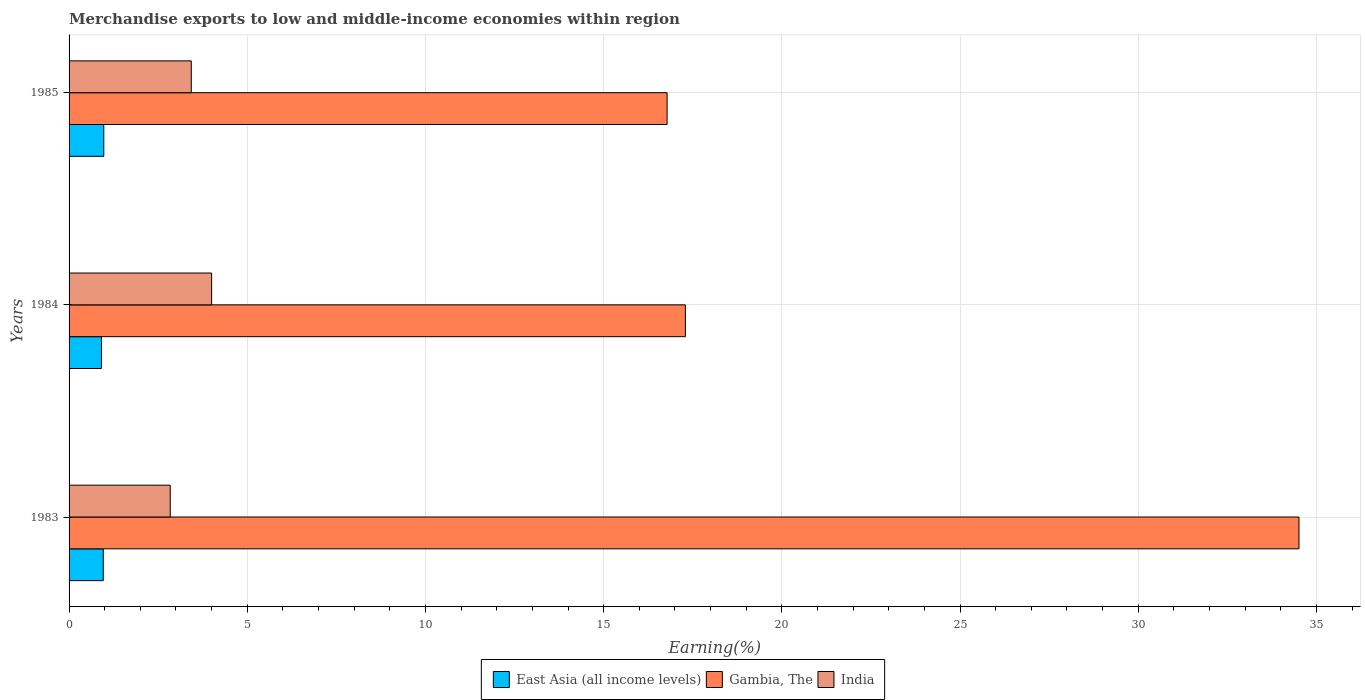How many different coloured bars are there?
Your response must be concise. 3. What is the percentage of amount earned from merchandise exports in East Asia (all income levels) in 1984?
Make the answer very short. 0.91. Across all years, what is the maximum percentage of amount earned from merchandise exports in East Asia (all income levels)?
Your answer should be very brief. 0.97. Across all years, what is the minimum percentage of amount earned from merchandise exports in Gambia, The?
Offer a very short reply. 16.78. What is the total percentage of amount earned from merchandise exports in East Asia (all income levels) in the graph?
Make the answer very short. 2.84. What is the difference between the percentage of amount earned from merchandise exports in India in 1983 and that in 1984?
Keep it short and to the point. -1.16. What is the difference between the percentage of amount earned from merchandise exports in East Asia (all income levels) in 1983 and the percentage of amount earned from merchandise exports in Gambia, The in 1984?
Give a very brief answer. -16.33. What is the average percentage of amount earned from merchandise exports in Gambia, The per year?
Provide a succinct answer. 22.86. In the year 1983, what is the difference between the percentage of amount earned from merchandise exports in India and percentage of amount earned from merchandise exports in East Asia (all income levels)?
Give a very brief answer. 1.88. In how many years, is the percentage of amount earned from merchandise exports in India greater than 13 %?
Keep it short and to the point. 0. What is the ratio of the percentage of amount earned from merchandise exports in India in 1983 to that in 1984?
Make the answer very short. 0.71. What is the difference between the highest and the second highest percentage of amount earned from merchandise exports in India?
Your answer should be compact. 0.57. What is the difference between the highest and the lowest percentage of amount earned from merchandise exports in India?
Give a very brief answer. 1.16. In how many years, is the percentage of amount earned from merchandise exports in East Asia (all income levels) greater than the average percentage of amount earned from merchandise exports in East Asia (all income levels) taken over all years?
Provide a succinct answer. 2. Is the sum of the percentage of amount earned from merchandise exports in India in 1984 and 1985 greater than the maximum percentage of amount earned from merchandise exports in East Asia (all income levels) across all years?
Provide a succinct answer. Yes. What does the 2nd bar from the top in 1983 represents?
Make the answer very short. Gambia, The. What does the 3rd bar from the bottom in 1983 represents?
Your answer should be very brief. India. Is it the case that in every year, the sum of the percentage of amount earned from merchandise exports in East Asia (all income levels) and percentage of amount earned from merchandise exports in India is greater than the percentage of amount earned from merchandise exports in Gambia, The?
Give a very brief answer. No. How many bars are there?
Your answer should be compact. 9. Are all the bars in the graph horizontal?
Give a very brief answer. Yes. How many years are there in the graph?
Offer a terse response. 3. What is the difference between two consecutive major ticks on the X-axis?
Ensure brevity in your answer.  5. Does the graph contain any zero values?
Give a very brief answer. No. Where does the legend appear in the graph?
Give a very brief answer. Bottom center. How many legend labels are there?
Provide a short and direct response. 3. How are the legend labels stacked?
Keep it short and to the point. Horizontal. What is the title of the graph?
Provide a short and direct response. Merchandise exports to low and middle-income economies within region. What is the label or title of the X-axis?
Your answer should be compact. Earning(%). What is the label or title of the Y-axis?
Your answer should be compact. Years. What is the Earning(%) of East Asia (all income levels) in 1983?
Provide a succinct answer. 0.96. What is the Earning(%) of Gambia, The in 1983?
Offer a very short reply. 34.51. What is the Earning(%) in India in 1983?
Offer a terse response. 2.84. What is the Earning(%) of East Asia (all income levels) in 1984?
Ensure brevity in your answer.  0.91. What is the Earning(%) of Gambia, The in 1984?
Your answer should be very brief. 17.29. What is the Earning(%) in India in 1984?
Offer a very short reply. 4. What is the Earning(%) of East Asia (all income levels) in 1985?
Ensure brevity in your answer.  0.97. What is the Earning(%) of Gambia, The in 1985?
Provide a short and direct response. 16.78. What is the Earning(%) of India in 1985?
Your response must be concise. 3.43. Across all years, what is the maximum Earning(%) of East Asia (all income levels)?
Give a very brief answer. 0.97. Across all years, what is the maximum Earning(%) of Gambia, The?
Keep it short and to the point. 34.51. Across all years, what is the maximum Earning(%) of India?
Your answer should be very brief. 4. Across all years, what is the minimum Earning(%) of East Asia (all income levels)?
Offer a terse response. 0.91. Across all years, what is the minimum Earning(%) of Gambia, The?
Your response must be concise. 16.78. Across all years, what is the minimum Earning(%) in India?
Your answer should be compact. 2.84. What is the total Earning(%) of East Asia (all income levels) in the graph?
Ensure brevity in your answer.  2.84. What is the total Earning(%) in Gambia, The in the graph?
Your answer should be very brief. 68.59. What is the total Earning(%) of India in the graph?
Offer a very short reply. 10.27. What is the difference between the Earning(%) of East Asia (all income levels) in 1983 and that in 1984?
Offer a terse response. 0.05. What is the difference between the Earning(%) in Gambia, The in 1983 and that in 1984?
Offer a very short reply. 17.22. What is the difference between the Earning(%) of India in 1983 and that in 1984?
Keep it short and to the point. -1.16. What is the difference between the Earning(%) of East Asia (all income levels) in 1983 and that in 1985?
Your answer should be compact. -0.01. What is the difference between the Earning(%) in Gambia, The in 1983 and that in 1985?
Your answer should be compact. 17.73. What is the difference between the Earning(%) in India in 1983 and that in 1985?
Keep it short and to the point. -0.59. What is the difference between the Earning(%) in East Asia (all income levels) in 1984 and that in 1985?
Make the answer very short. -0.07. What is the difference between the Earning(%) in Gambia, The in 1984 and that in 1985?
Ensure brevity in your answer.  0.51. What is the difference between the Earning(%) of India in 1984 and that in 1985?
Keep it short and to the point. 0.57. What is the difference between the Earning(%) in East Asia (all income levels) in 1983 and the Earning(%) in Gambia, The in 1984?
Keep it short and to the point. -16.33. What is the difference between the Earning(%) of East Asia (all income levels) in 1983 and the Earning(%) of India in 1984?
Make the answer very short. -3.04. What is the difference between the Earning(%) of Gambia, The in 1983 and the Earning(%) of India in 1984?
Your answer should be very brief. 30.51. What is the difference between the Earning(%) of East Asia (all income levels) in 1983 and the Earning(%) of Gambia, The in 1985?
Make the answer very short. -15.82. What is the difference between the Earning(%) of East Asia (all income levels) in 1983 and the Earning(%) of India in 1985?
Provide a succinct answer. -2.47. What is the difference between the Earning(%) of Gambia, The in 1983 and the Earning(%) of India in 1985?
Your response must be concise. 31.08. What is the difference between the Earning(%) in East Asia (all income levels) in 1984 and the Earning(%) in Gambia, The in 1985?
Offer a terse response. -15.87. What is the difference between the Earning(%) of East Asia (all income levels) in 1984 and the Earning(%) of India in 1985?
Provide a short and direct response. -2.52. What is the difference between the Earning(%) of Gambia, The in 1984 and the Earning(%) of India in 1985?
Your answer should be very brief. 13.86. What is the average Earning(%) of East Asia (all income levels) per year?
Offer a very short reply. 0.95. What is the average Earning(%) in Gambia, The per year?
Your answer should be very brief. 22.86. What is the average Earning(%) in India per year?
Make the answer very short. 3.42. In the year 1983, what is the difference between the Earning(%) of East Asia (all income levels) and Earning(%) of Gambia, The?
Keep it short and to the point. -33.55. In the year 1983, what is the difference between the Earning(%) of East Asia (all income levels) and Earning(%) of India?
Keep it short and to the point. -1.88. In the year 1983, what is the difference between the Earning(%) in Gambia, The and Earning(%) in India?
Ensure brevity in your answer.  31.67. In the year 1984, what is the difference between the Earning(%) of East Asia (all income levels) and Earning(%) of Gambia, The?
Your answer should be compact. -16.39. In the year 1984, what is the difference between the Earning(%) in East Asia (all income levels) and Earning(%) in India?
Your answer should be very brief. -3.09. In the year 1984, what is the difference between the Earning(%) of Gambia, The and Earning(%) of India?
Your response must be concise. 13.29. In the year 1985, what is the difference between the Earning(%) of East Asia (all income levels) and Earning(%) of Gambia, The?
Provide a short and direct response. -15.81. In the year 1985, what is the difference between the Earning(%) of East Asia (all income levels) and Earning(%) of India?
Keep it short and to the point. -2.46. In the year 1985, what is the difference between the Earning(%) in Gambia, The and Earning(%) in India?
Ensure brevity in your answer.  13.35. What is the ratio of the Earning(%) in East Asia (all income levels) in 1983 to that in 1984?
Offer a very short reply. 1.06. What is the ratio of the Earning(%) in Gambia, The in 1983 to that in 1984?
Ensure brevity in your answer.  2. What is the ratio of the Earning(%) of India in 1983 to that in 1984?
Provide a short and direct response. 0.71. What is the ratio of the Earning(%) in Gambia, The in 1983 to that in 1985?
Provide a short and direct response. 2.06. What is the ratio of the Earning(%) of India in 1983 to that in 1985?
Offer a very short reply. 0.83. What is the ratio of the Earning(%) of East Asia (all income levels) in 1984 to that in 1985?
Give a very brief answer. 0.93. What is the ratio of the Earning(%) of Gambia, The in 1984 to that in 1985?
Give a very brief answer. 1.03. What is the ratio of the Earning(%) of India in 1984 to that in 1985?
Keep it short and to the point. 1.17. What is the difference between the highest and the second highest Earning(%) in East Asia (all income levels)?
Make the answer very short. 0.01. What is the difference between the highest and the second highest Earning(%) in Gambia, The?
Provide a succinct answer. 17.22. What is the difference between the highest and the second highest Earning(%) in India?
Your answer should be very brief. 0.57. What is the difference between the highest and the lowest Earning(%) in East Asia (all income levels)?
Make the answer very short. 0.07. What is the difference between the highest and the lowest Earning(%) of Gambia, The?
Ensure brevity in your answer.  17.73. What is the difference between the highest and the lowest Earning(%) in India?
Your response must be concise. 1.16. 